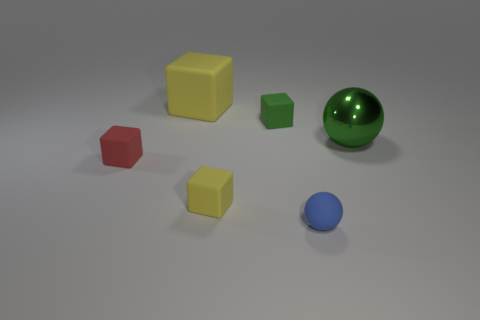What is the material of the small object that is the same color as the metallic sphere?
Provide a succinct answer. Rubber. What material is the green thing that is the same shape as the blue rubber object?
Your answer should be compact. Metal. What number of shiny things are tiny blue blocks or tiny blue balls?
Your answer should be compact. 0. There is a thing that is both in front of the tiny green matte thing and behind the tiny red object; what material is it?
Your answer should be very brief. Metal. Is the blue sphere made of the same material as the tiny yellow object?
Your response must be concise. Yes. What is the size of the matte object that is both on the right side of the tiny yellow cube and on the left side of the rubber sphere?
Make the answer very short. Small. What is the shape of the small red thing?
Give a very brief answer. Cube. How many things are rubber spheres or objects behind the matte sphere?
Provide a succinct answer. 6. There is a big thing that is to the right of the tiny blue sphere; is it the same color as the small sphere?
Offer a terse response. No. What color is the block that is both in front of the green rubber cube and on the left side of the small yellow matte object?
Ensure brevity in your answer.  Red. 